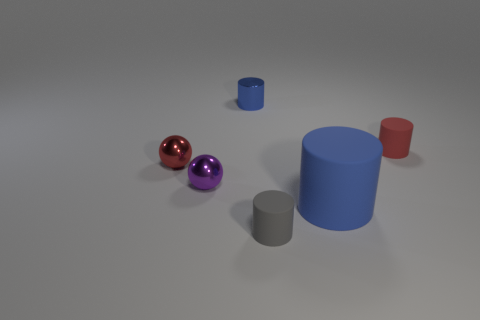What number of other objects are the same color as the small shiny cylinder?
Offer a terse response. 1. How many matte objects are both to the right of the small gray cylinder and to the left of the red cylinder?
Give a very brief answer. 1. There is a red matte object; what shape is it?
Your answer should be very brief. Cylinder. There is a tiny metallic sphere that is in front of the red object that is on the left side of the tiny rubber cylinder in front of the purple thing; what color is it?
Give a very brief answer. Purple. There is a purple ball that is the same size as the metal cylinder; what is its material?
Your answer should be compact. Metal. What number of objects are objects that are on the right side of the tiny gray object or tiny things?
Ensure brevity in your answer.  6. Are any small green cubes visible?
Give a very brief answer. No. There is a blue object that is in front of the red cylinder; what is its material?
Provide a short and direct response. Rubber. There is another cylinder that is the same color as the big cylinder; what is it made of?
Your response must be concise. Metal. How many tiny objects are either matte cylinders or metal balls?
Offer a terse response. 4. 